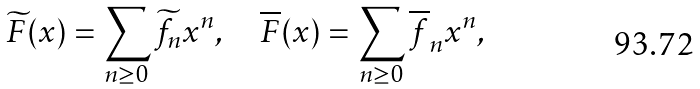<formula> <loc_0><loc_0><loc_500><loc_500>\widetilde { F } ( x ) = \sum _ { n \geq 0 } \widetilde { f } _ { n } x ^ { n } , \quad \overline { F } ( x ) = \sum _ { n \geq 0 } \overline { f } _ { n } x ^ { n } ,</formula> 